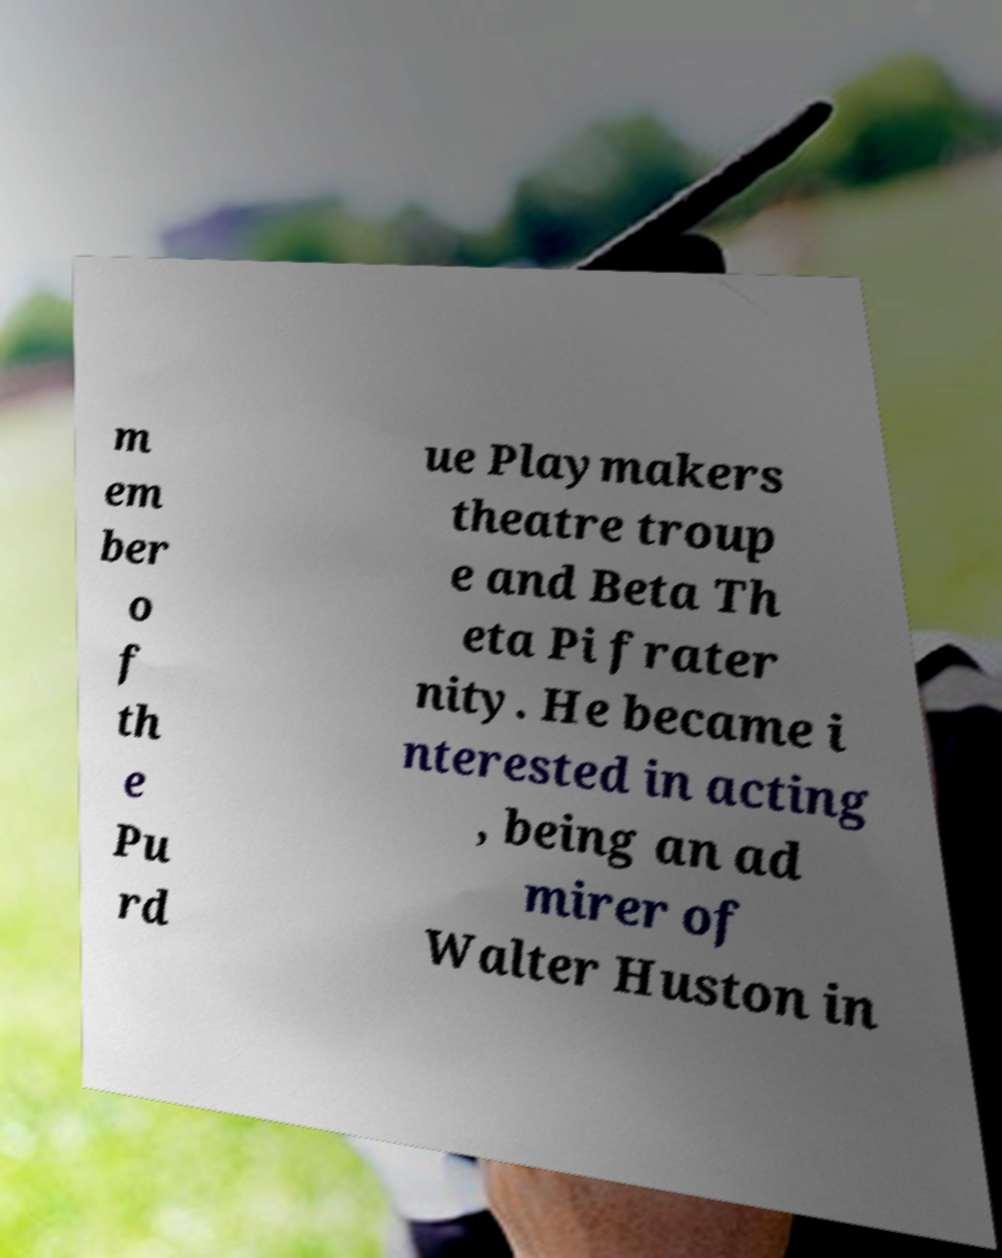Please identify and transcribe the text found in this image. m em ber o f th e Pu rd ue Playmakers theatre troup e and Beta Th eta Pi frater nity. He became i nterested in acting , being an ad mirer of Walter Huston in 